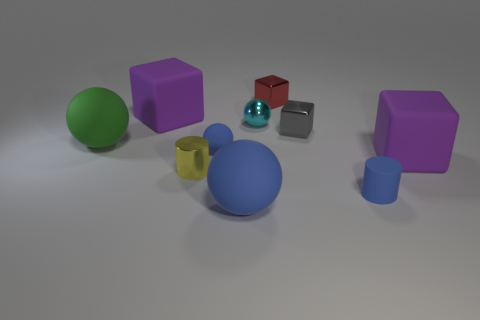Subtract 1 spheres. How many spheres are left? 3 Subtract all balls. How many objects are left? 6 Subtract all brown metallic spheres. Subtract all green spheres. How many objects are left? 9 Add 8 tiny metal cubes. How many tiny metal cubes are left? 10 Add 2 cyan blocks. How many cyan blocks exist? 2 Subtract 1 green spheres. How many objects are left? 9 